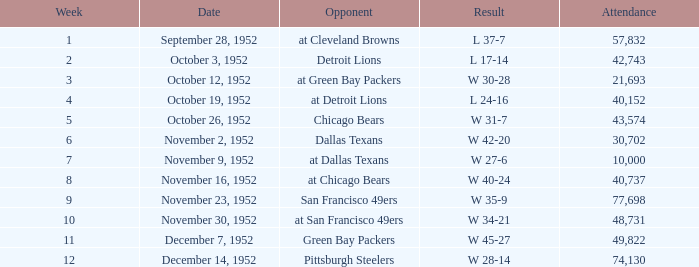When is the last week that has a result of a w 34-21? 10.0. 